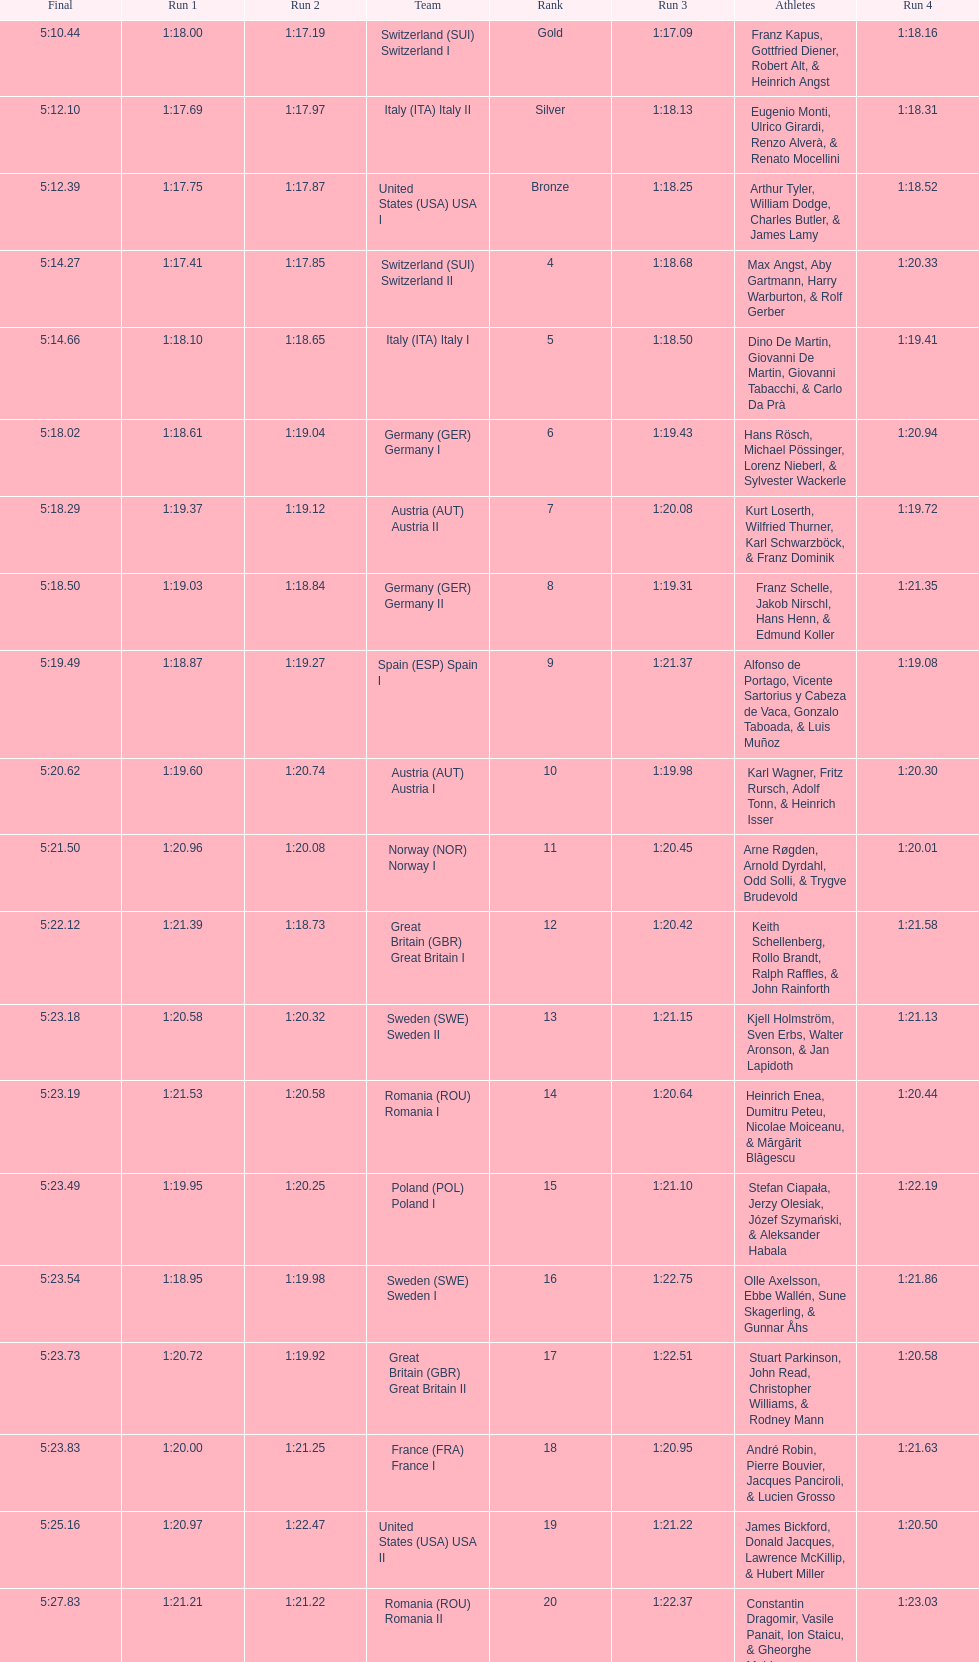What is the total amount of runs? 4. 